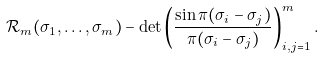<formula> <loc_0><loc_0><loc_500><loc_500>\mathcal { R } _ { m } ( \sigma _ { 1 } , \dots , \sigma _ { m } ) - \det \left ( \frac { \sin \pi ( \sigma _ { i } - \sigma _ { j } ) } { \pi ( \sigma _ { i } - \sigma _ { j } ) } \right ) _ { i , j = 1 } ^ { m } .</formula> 